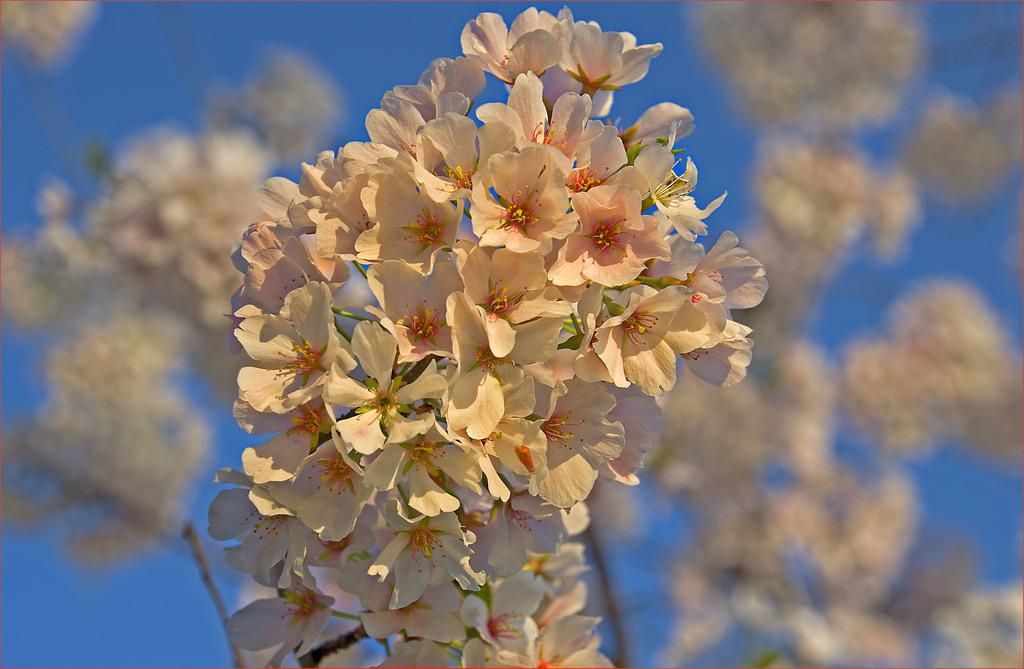What type of living organisms can be seen in the image? There are flowers in the image. Can you describe the background of the image? The background of the image is blurred. What current is being used to power the flowers in the image? There is no indication in the image that the flowers are powered by any current. 